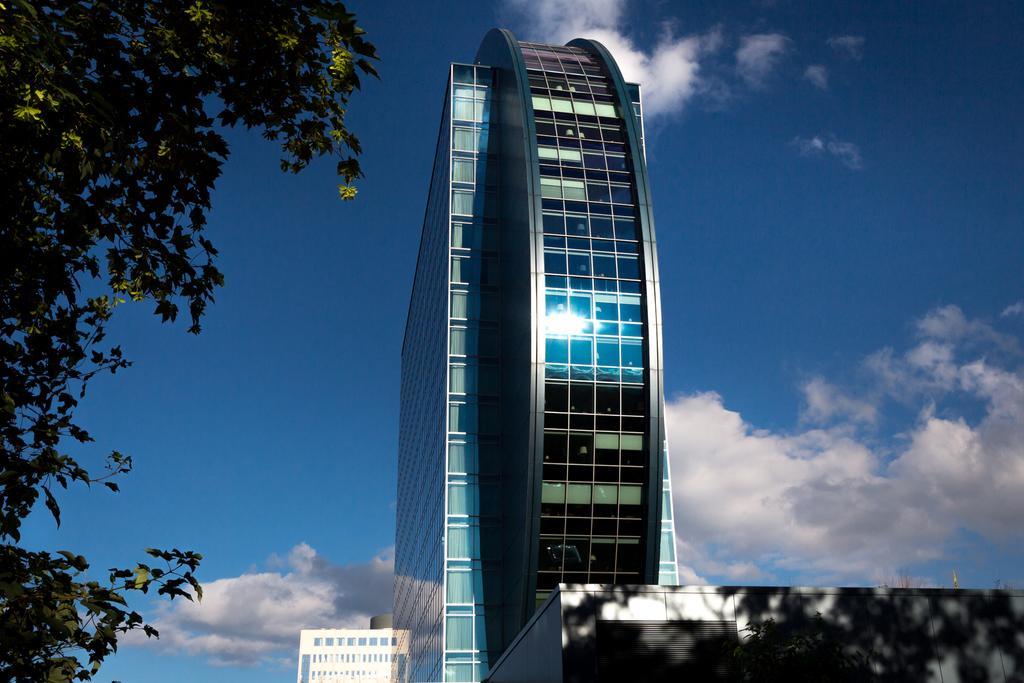In one or two sentences, can you explain what this image depicts? In this image we can see buildings with glass windows. Background of the image we can see the sky with clouds. We can see tree on the left side of the image. 